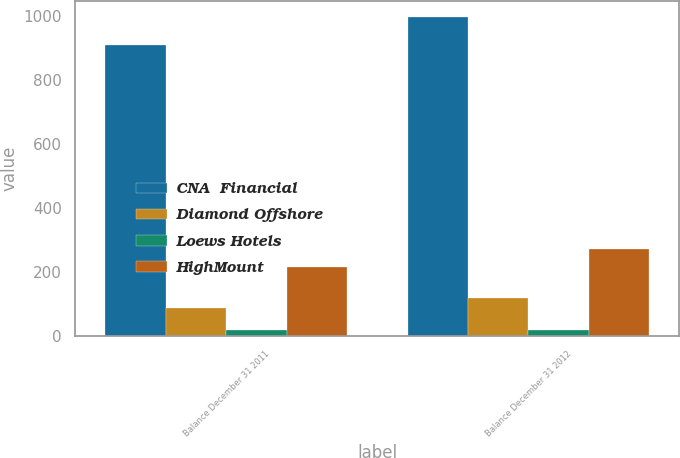<chart> <loc_0><loc_0><loc_500><loc_500><stacked_bar_chart><ecel><fcel>Balance December 31 2011<fcel>Balance December 31 2012<nl><fcel>CNA  Financial<fcel>908<fcel>996<nl><fcel>Diamond Offshore<fcel>86<fcel>118<nl><fcel>Loews Hotels<fcel>20<fcel>20<nl><fcel>HighMount<fcel>215<fcel>271<nl></chart> 